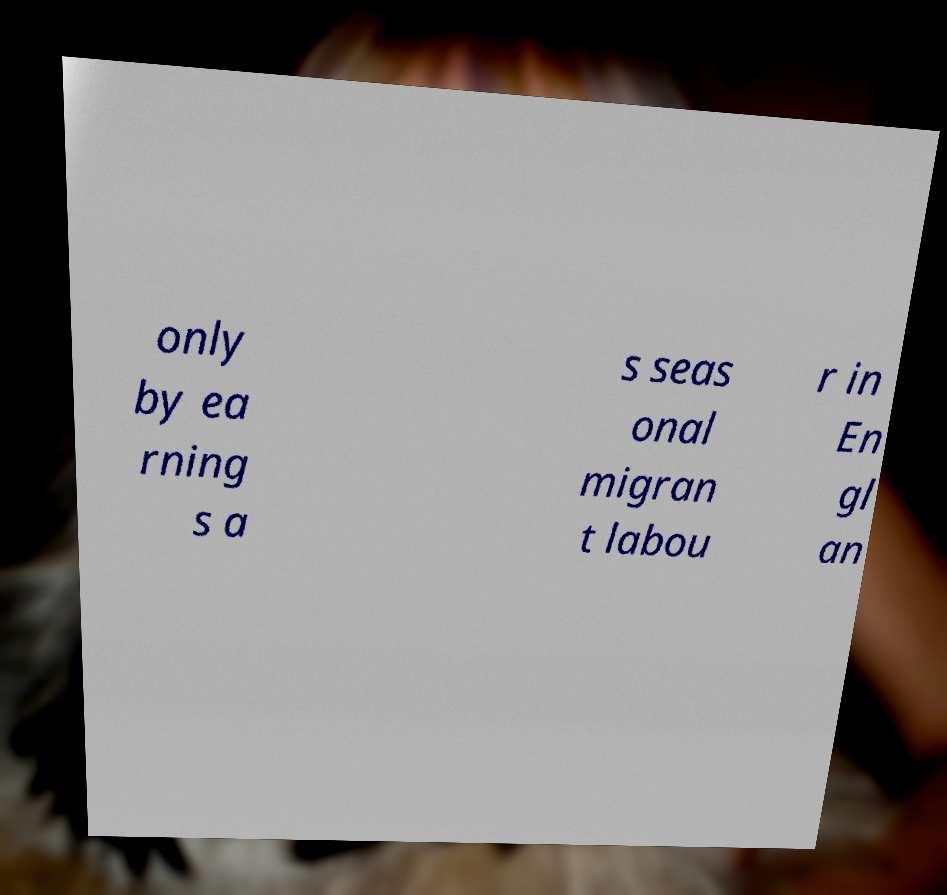I need the written content from this picture converted into text. Can you do that? only by ea rning s a s seas onal migran t labou r in En gl an 